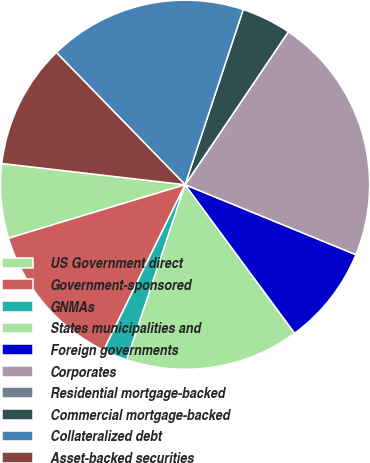<chart> <loc_0><loc_0><loc_500><loc_500><pie_chart><fcel>US Government direct<fcel>Government-sponsored<fcel>GNMAs<fcel>States municipalities and<fcel>Foreign governments<fcel>Corporates<fcel>Residential mortgage-backed<fcel>Commercial mortgage-backed<fcel>Collateralized debt<fcel>Asset-backed securities<nl><fcel>6.52%<fcel>13.04%<fcel>2.17%<fcel>15.22%<fcel>8.7%<fcel>21.74%<fcel>0.0%<fcel>4.35%<fcel>17.39%<fcel>10.87%<nl></chart> 